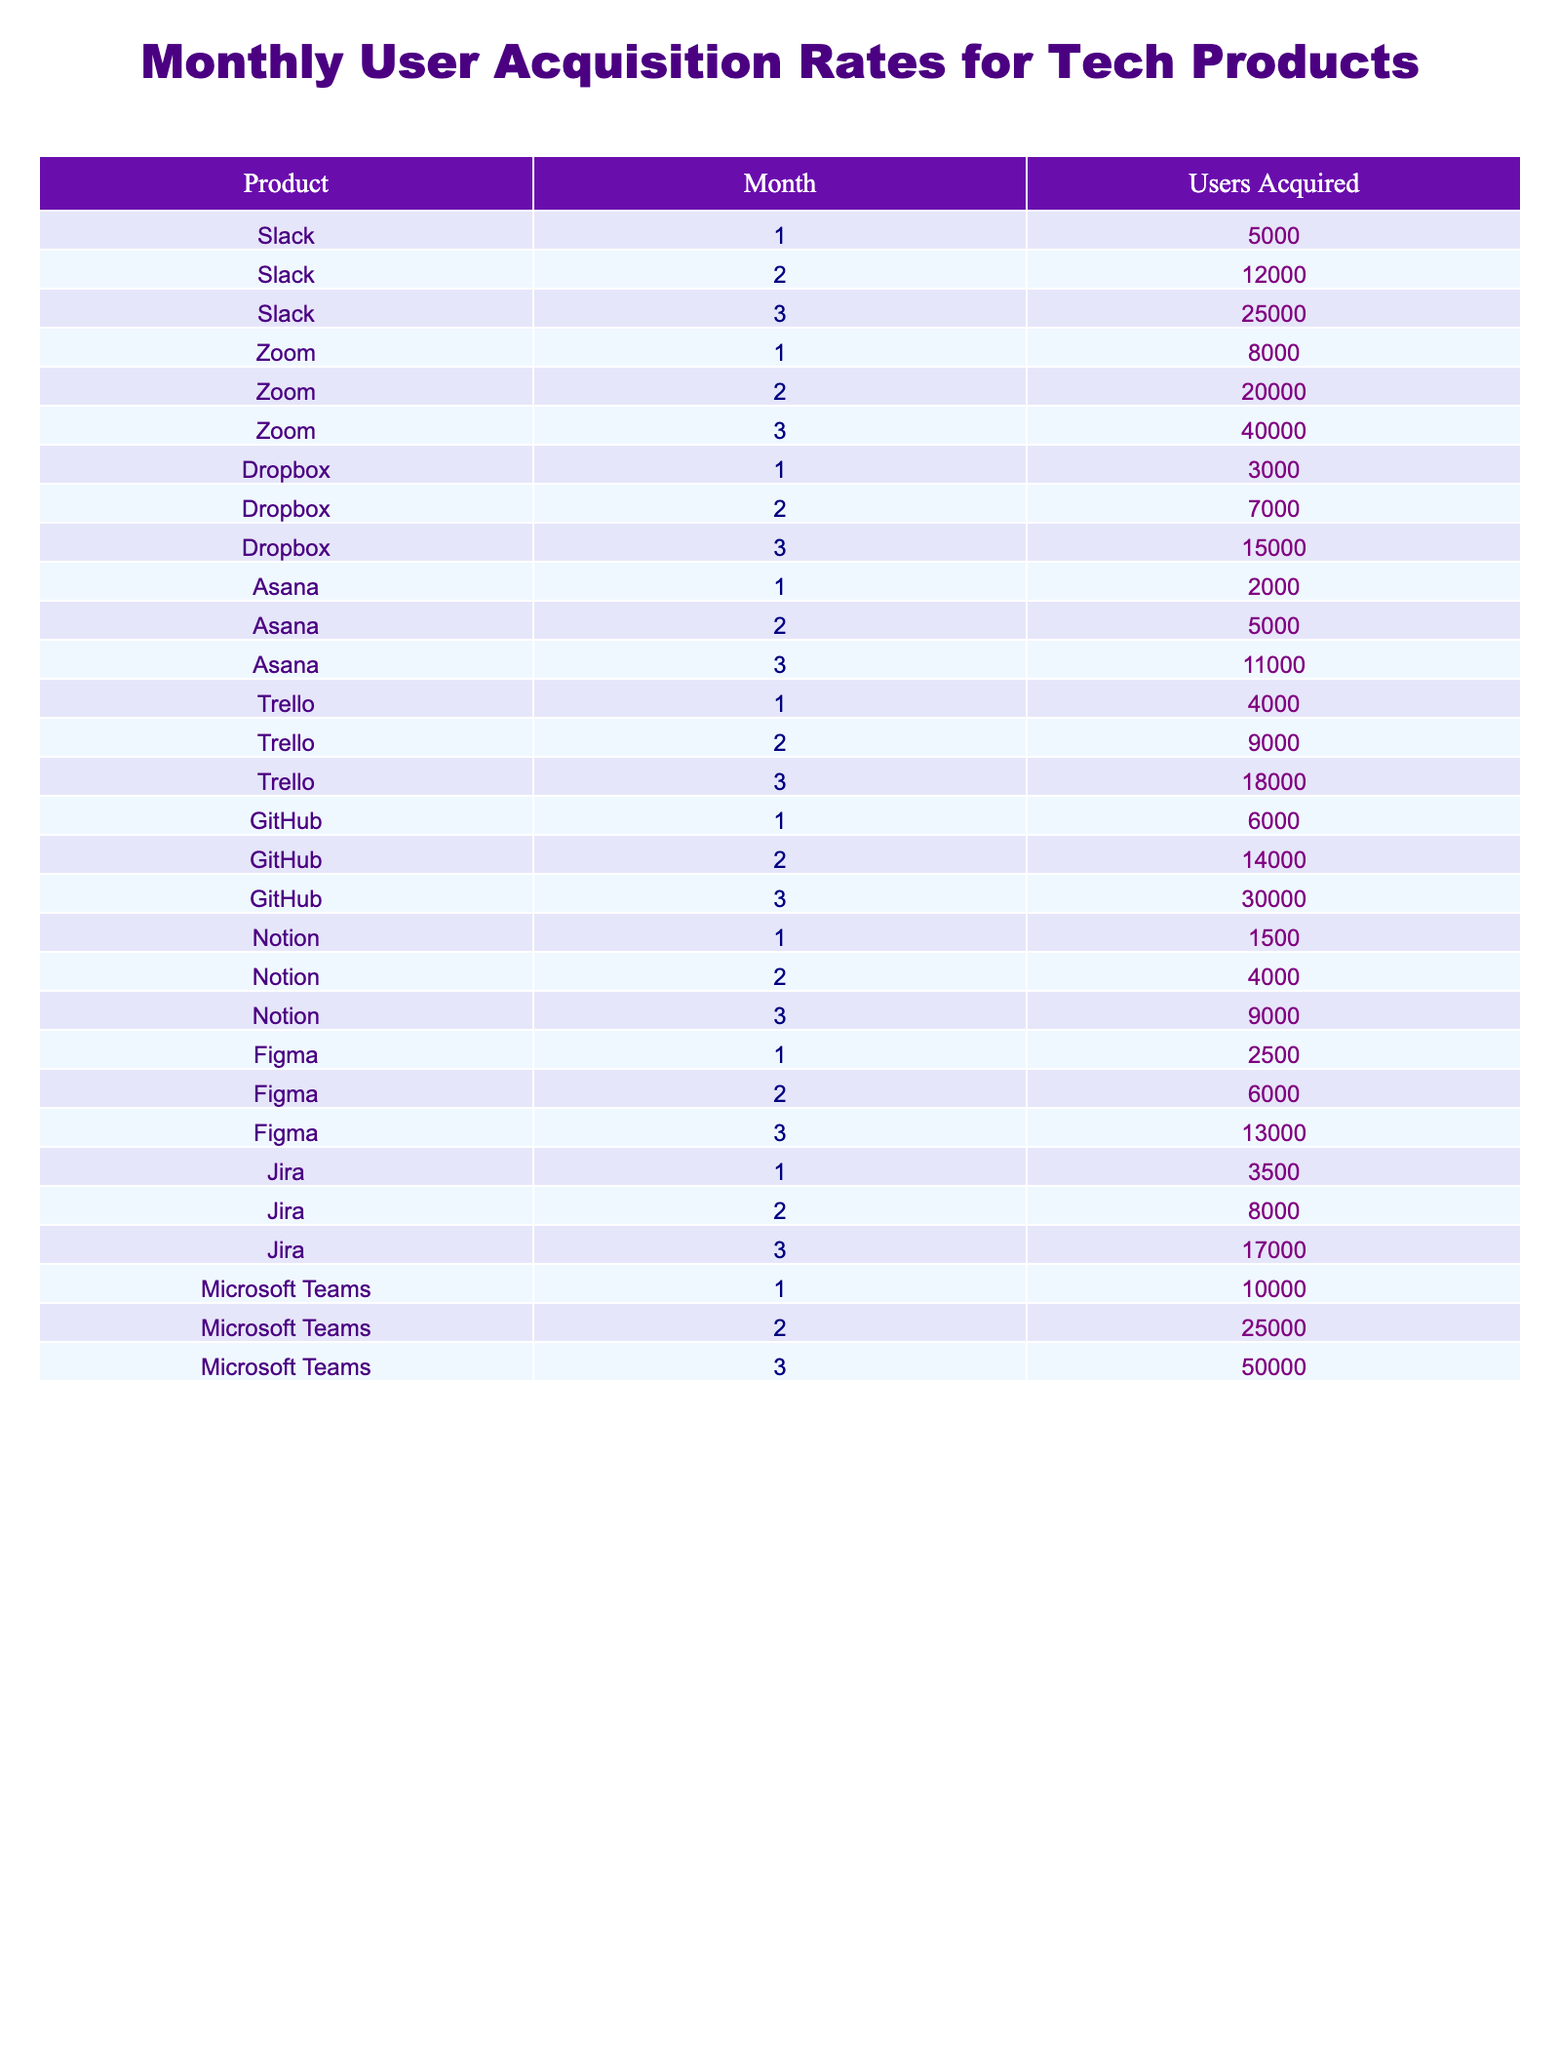What is the total number of users acquired by Slack in the first three months? By summing the users acquired in all three months for Slack: 5000 (Month 1) + 12000 (Month 2) + 25000 (Month 3) = 42000.
Answer: 42000 Which product had the highest user acquisition in Month 2? In Month 2, the user acquisitions were: Slack 12000, Zoom 20000, Dropbox 7000, Asana 5000, Trello 9000, GitHub 14000, Notion 4000, Figma 6000, Jira 8000, and Microsoft Teams 25000. The highest is Microsoft Teams with 25000.
Answer: Microsoft Teams Is it true that Asana acquired more users than Trello in Month 3? In Month 3, Asana had 11000 users and Trello had 18000 users. Since 11000 < 18000, it is false that Asana acquired more users than Trello.
Answer: False What is the average user acquisition of GitHub over the three months? For GitHub, the user acquisitions are: 6000 (Month 1), 14000 (Month 2), and 30000 (Month 3). The total is 6000 + 14000 + 30000 = 50000, and dividing by 3 gives an average of 50000 / 3 = 16666.67.
Answer: 16666.67 Which product had the lowest total user acquisition over the three months? Summing up the total user acquisitions for each product: Slack (42000), Zoom (68000), Dropbox (24000), Asana (11000), Trello (36000), GitHub (50000), Notion (14500), Figma (21000), Jira (36000), Microsoft Teams (85000). The lowest is Asana with 11000.
Answer: Asana In which month did Microsoft Teams see the highest user acquisition rate? Microsoft Teams had 10000, 25000, and 50000 users in Months 1, 2, and 3 respectively. The highest value is 50000 in Month 3.
Answer: Month 3 How many more users did Zoom acquire in Month 3 compared to Month 1? Zoom acquired 40000 users in Month 3 and 8000 in Month 1. The difference is 40000 - 8000 = 32000.
Answer: 32000 Was the user acquisition for Figma consistently increasing over the three months? Figma had user acquisitions of: 2500 (Month 1), 6000 (Month 2), and 13000 (Month 3). Since each month has a higher number than the previous, it is true that it was consistently increasing.
Answer: True If we compare the total user acquisitions of Dropbox, Asana, and Notion, which one is the highest? Total for Dropbox is 24000, Asana is 11000, and Notion is 14500. By comparing these totals, Dropbox has the highest acquisition of 24000.
Answer: Dropbox How many users did Trello acquire in total over all three months combined? Trello acquired: 4000 (Month 1) + 9000 (Month 2) + 18000 (Month 3) = 30000.
Answer: 30000 Which product had the second highest user acquisition in Month 1? In Month 1, acquisitions were: Slack 5000, Zoom 8000, Dropbox 3000, Asana 2000, Trello 4000, GitHub 6000, Notion 1500, Figma 2500, Jira 3500, Microsoft Teams 10000. The second highest after Microsoft Teams (10000) is Zoom with 8000.
Answer: Zoom 